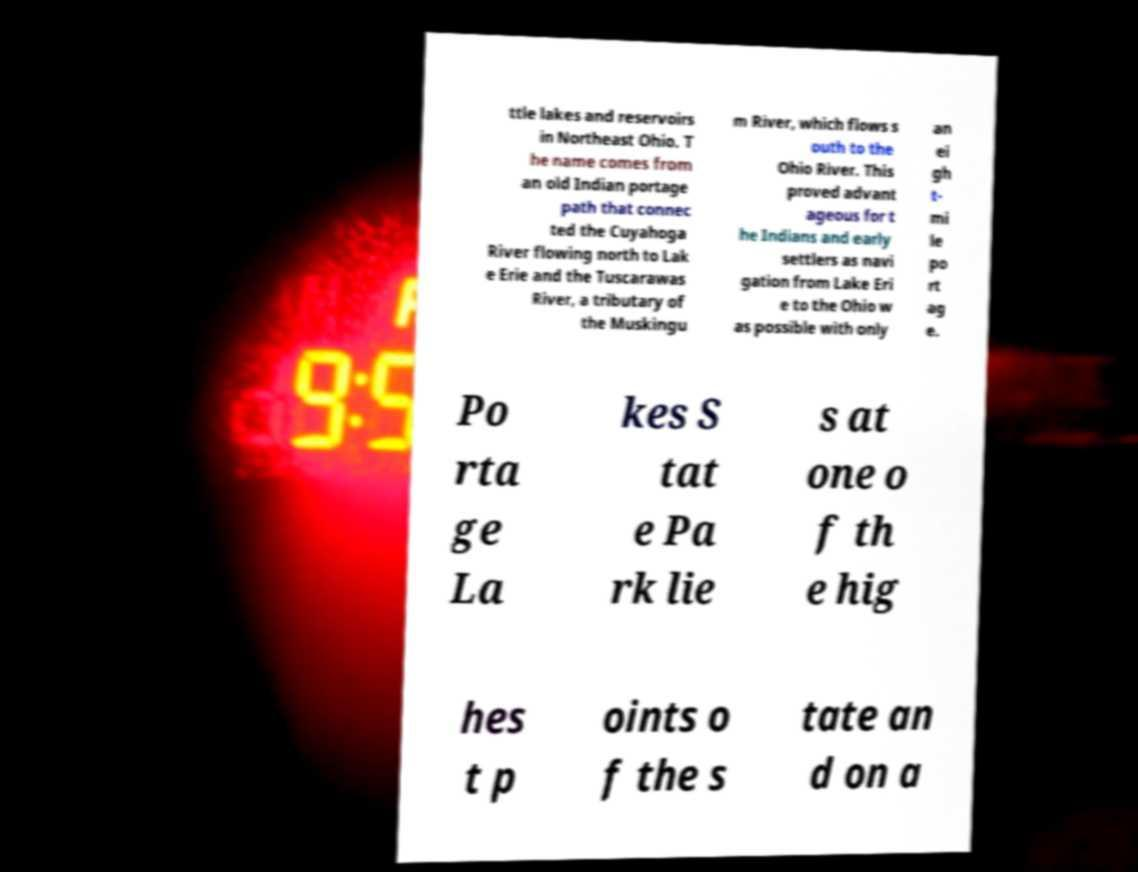There's text embedded in this image that I need extracted. Can you transcribe it verbatim? ttle lakes and reservoirs in Northeast Ohio. T he name comes from an old Indian portage path that connec ted the Cuyahoga River flowing north to Lak e Erie and the Tuscarawas River, a tributary of the Muskingu m River, which flows s outh to the Ohio River. This proved advant ageous for t he Indians and early settlers as navi gation from Lake Eri e to the Ohio w as possible with only an ei gh t- mi le po rt ag e. Po rta ge La kes S tat e Pa rk lie s at one o f th e hig hes t p oints o f the s tate an d on a 